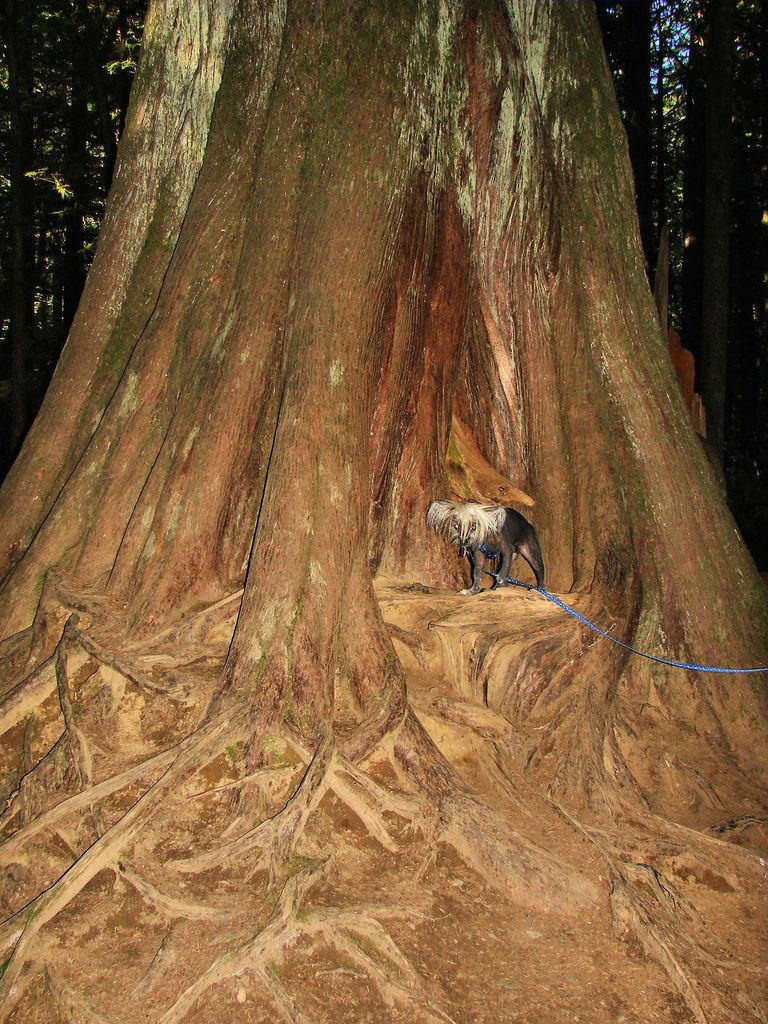What animal can be seen in the image? There is a dog in the image. Where is the dog located in relation to the trees? The dog is standing under a tree. How many trees are visible in the image? There are multiple trees visible in the image. What arithmetic problem is the dog solving under the tree? There is no arithmetic problem present in the image, as it features a dog standing under a tree. What type of branch is the dog holding in its mouth? There is no branch visible in the image, and the dog is not holding anything in its mouth. 